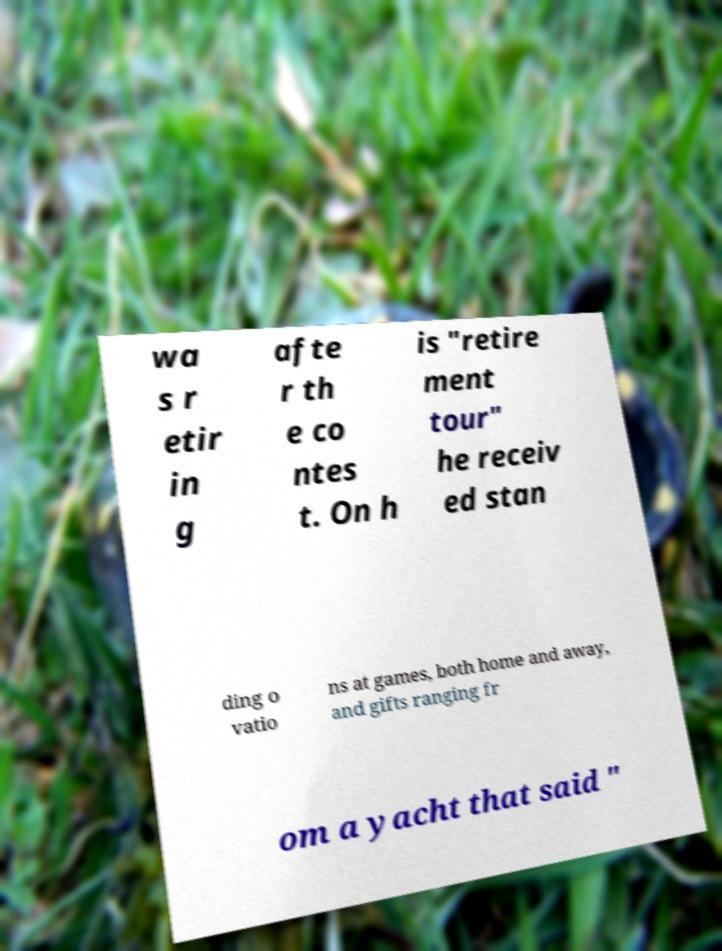Can you read and provide the text displayed in the image?This photo seems to have some interesting text. Can you extract and type it out for me? wa s r etir in g afte r th e co ntes t. On h is "retire ment tour" he receiv ed stan ding o vatio ns at games, both home and away, and gifts ranging fr om a yacht that said " 